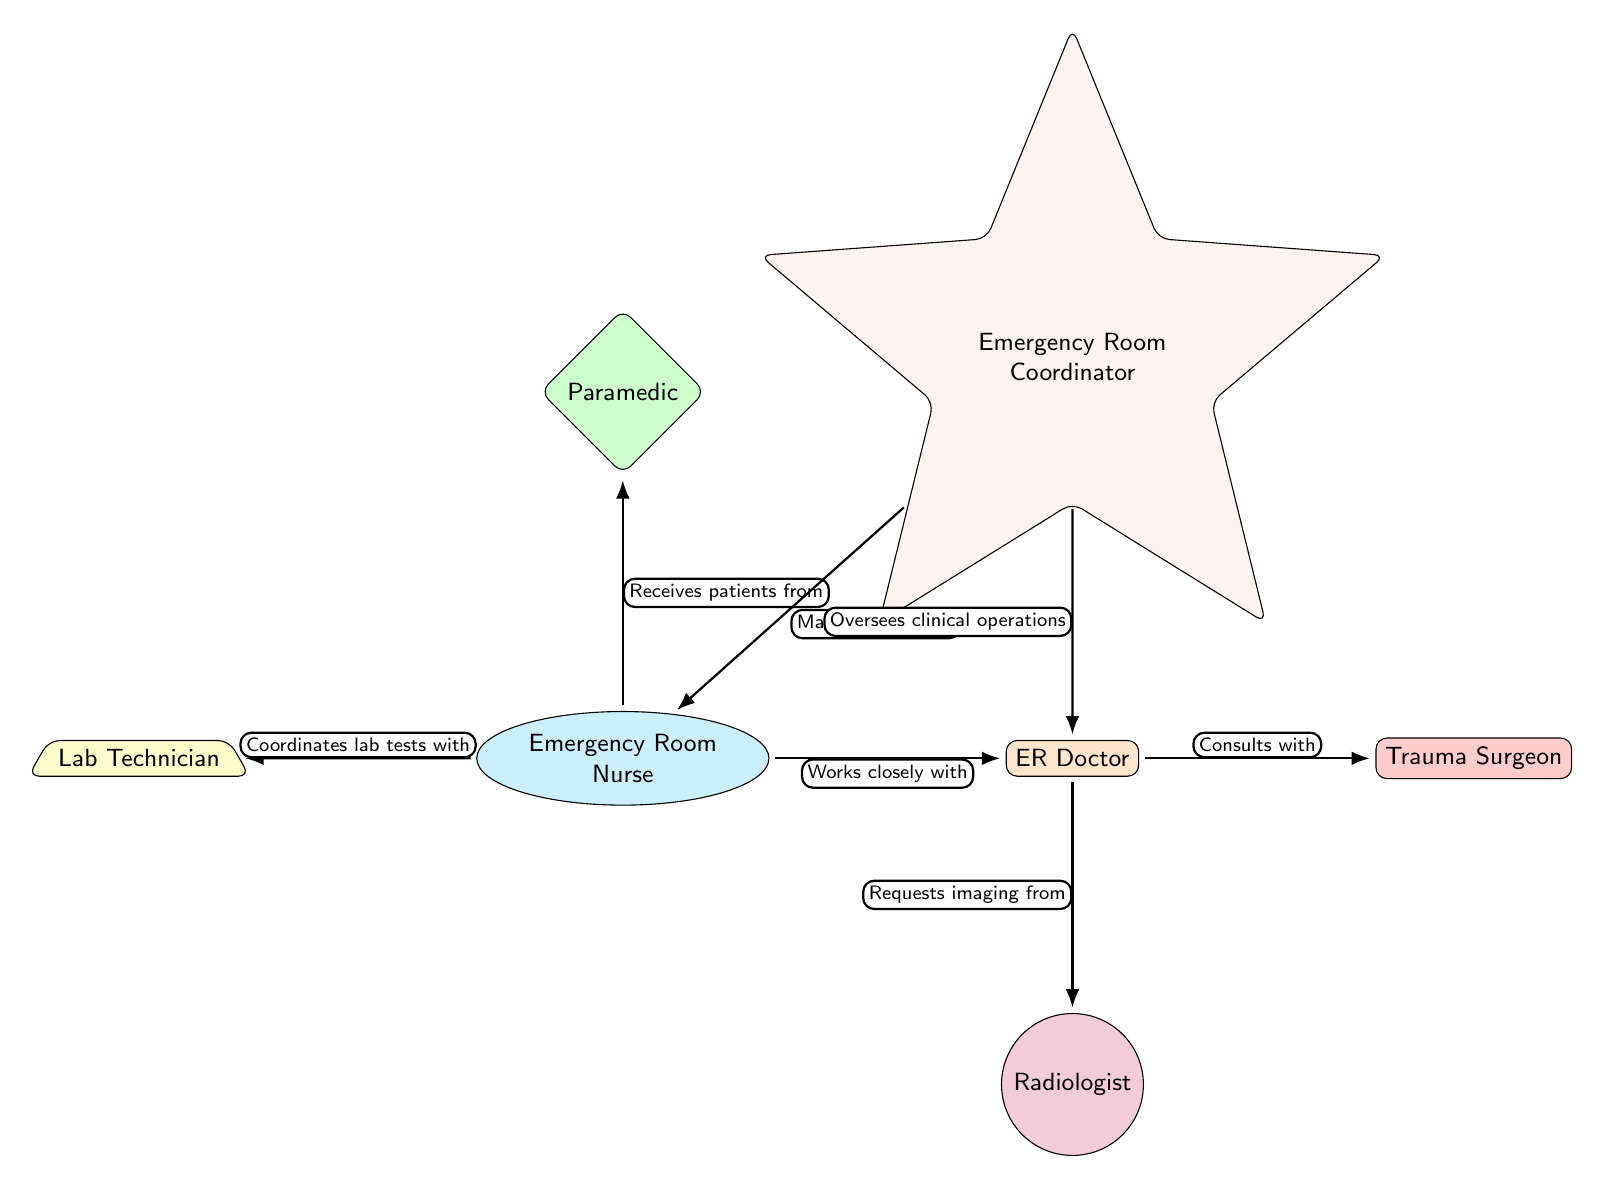What is the role directly collaborating with the Emergency Room Nurse? The Emergency Room Nurse works closely with the ER Doctor, as indicated by the edge connecting them labeled "Works closely with."
Answer: ER Doctor How many nodes are in the diagram? The diagram contains a total of seven nodes representing different roles in the emergency room team.
Answer: 7 Which role requests imaging from the ER Doctor? The ER Doctor requests imaging from the Radiologist, as shown by the edge labeled "Requests imaging from."
Answer: Radiologist Who manages workflow within the emergency room team? The Emergency Room Coordinator manages workflow, as indicated by the edge labeled "Manages workflow" from the coordinator to the Emergency Room Nurse.
Answer: Emergency Room Coordinator What type of relationship does the Lab Technician have with the Emergency Room Nurse? The relationship is defined as coordinating lab tests, indicated by the edge labeled "Coordinates lab tests with."
Answer: Coordinates lab tests with Which role oversees clinical operations in the office? The Emergency Room Coordinator oversees clinical operations, as noted in the edge labeled "Oversaw clinical operations."
Answer: Emergency Room Coordinator Determine the role that the Emergency Room Nurse receives patients from. The Emergency Room Nurse receives patients from the Paramedic, which is detailed in the edge marked "Receives patients from."
Answer: Paramedic What type of diagram is this? This is a Social Science Diagram, specifically focused on the collaboration patterns of emergency room teams.
Answer: Social Science Diagram Identify the number of edges coming out of the ER Doctor. The ER Doctor has two edges coming out: one to the Trauma Surgeon and another to the Radiologist.
Answer: 2 